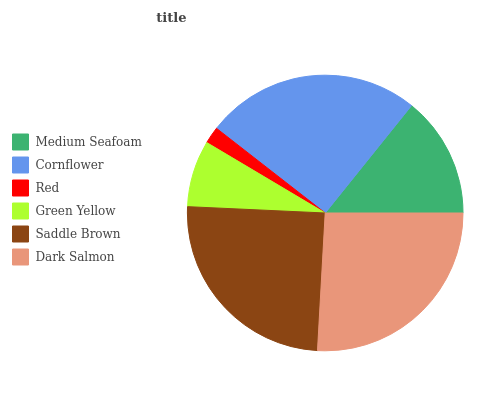Is Red the minimum?
Answer yes or no. Yes. Is Dark Salmon the maximum?
Answer yes or no. Yes. Is Cornflower the minimum?
Answer yes or no. No. Is Cornflower the maximum?
Answer yes or no. No. Is Cornflower greater than Medium Seafoam?
Answer yes or no. Yes. Is Medium Seafoam less than Cornflower?
Answer yes or no. Yes. Is Medium Seafoam greater than Cornflower?
Answer yes or no. No. Is Cornflower less than Medium Seafoam?
Answer yes or no. No. Is Saddle Brown the high median?
Answer yes or no. Yes. Is Medium Seafoam the low median?
Answer yes or no. Yes. Is Medium Seafoam the high median?
Answer yes or no. No. Is Green Yellow the low median?
Answer yes or no. No. 